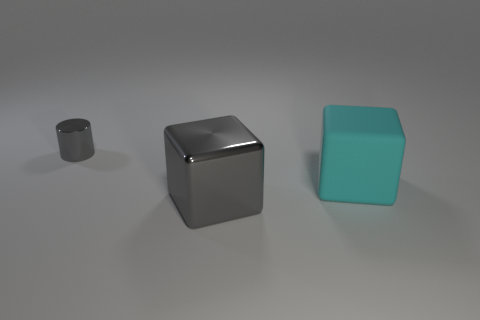Add 2 tiny metallic cylinders. How many objects exist? 5 Subtract all cubes. How many objects are left? 1 Add 2 metal blocks. How many metal blocks are left? 3 Add 3 cylinders. How many cylinders exist? 4 Subtract 0 blue balls. How many objects are left? 3 Subtract all blue matte cylinders. Subtract all gray cylinders. How many objects are left? 2 